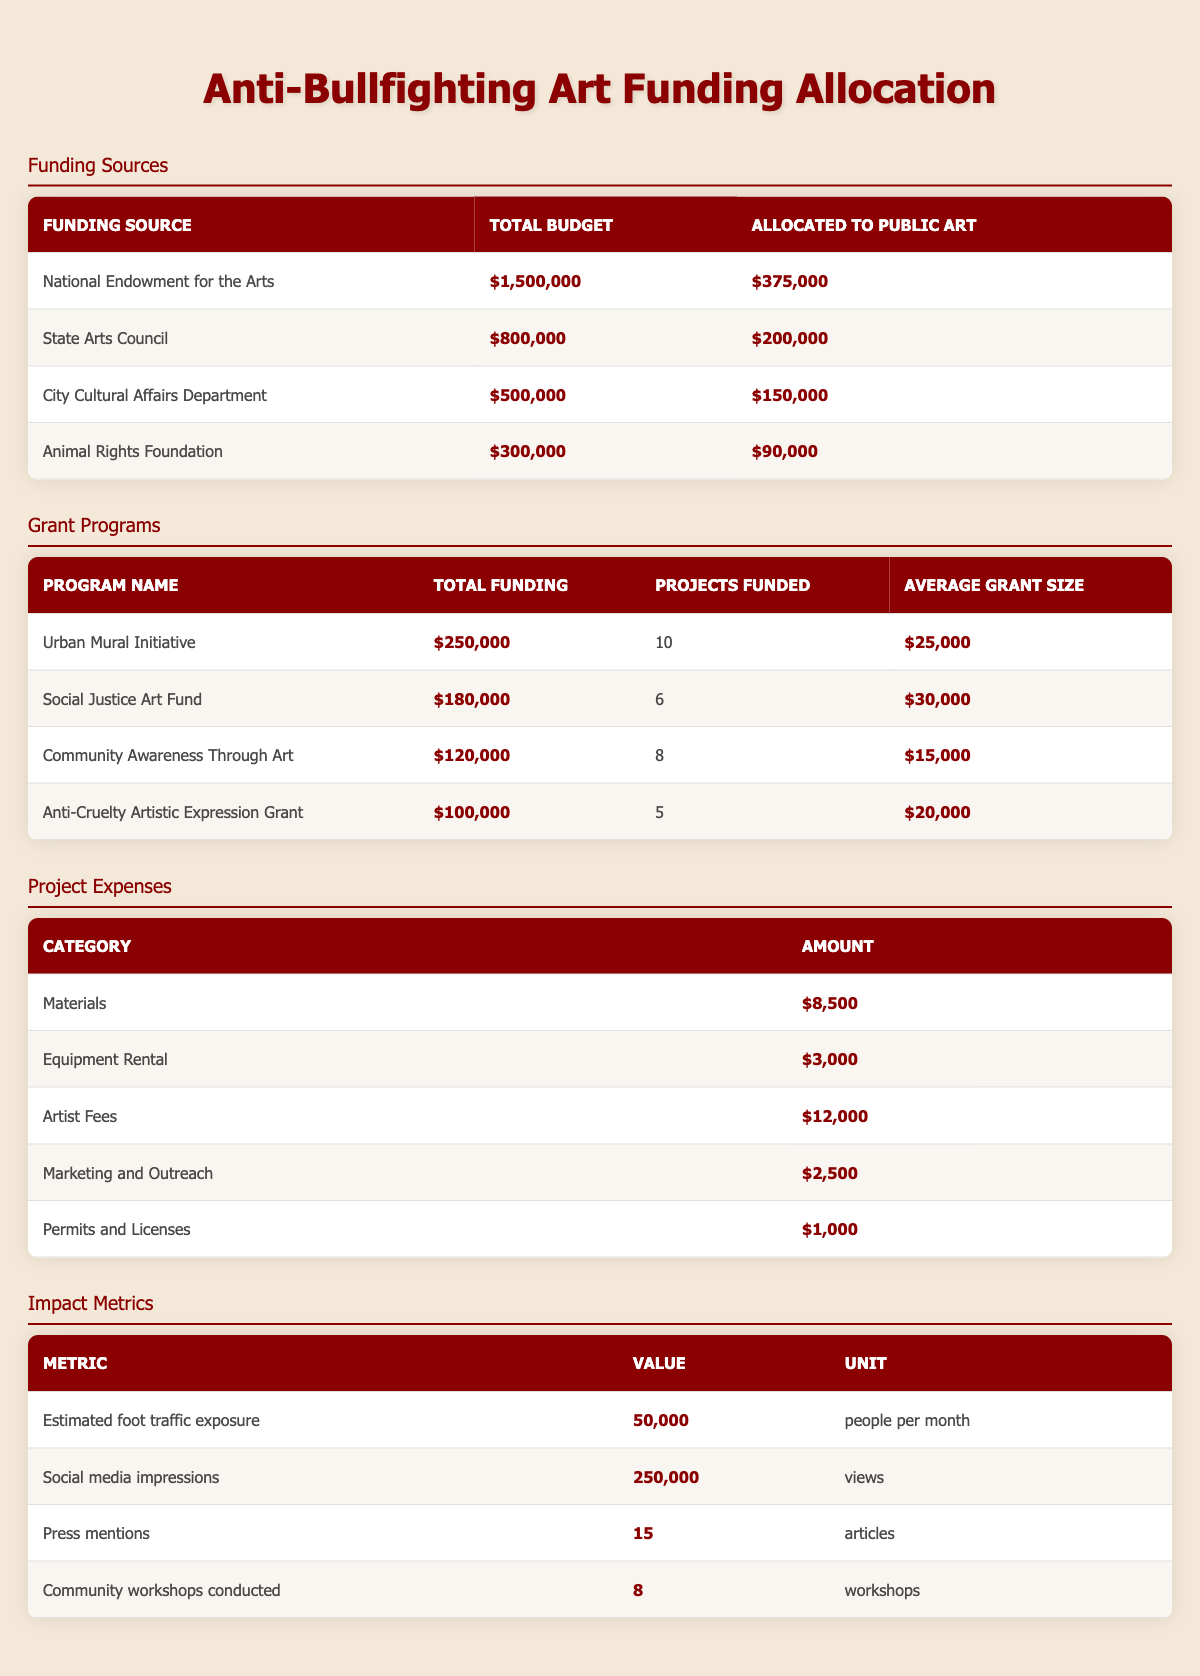What is the total amount allocated to public art from the National Endowment for the Arts? The total allocated amount for public art from the National Endowment for the Arts is listed as $375,000 in the table.
Answer: $375,000 What is the total funding for the Urban Mural Initiative? The table shows the Urban Mural Initiative's total funding amount as $250,000.
Answer: $250,000 How much more funding did the State Arts Council allocate to public art compared to the Animal Rights Foundation? The State Arts Council allocated $200,000 to public art while the Animal Rights Foundation allocated $90,000. The difference is calculated as $200,000 - $90,000 = $110,000.
Answer: $110,000 Are there more projects funded under the Social Justice Art Fund than the Anti-Cruelty Artistic Expression Grant? The Social Justice Art Fund funded 6 projects, while the Anti-Cruelty Artistic Expression Grant funded 5 projects. Since 6 is greater than 5, the answer is yes.
Answer: Yes What is the average amount spent on artist fees compared to materials? The artist fees amount is $12,000 and materials amount is $8,500. Average is calculated as ($12,000 + $8,500) / 2 = $10,250.
Answer: $10,250 What is the total amount allocated to public art across all funding sources? First, identify the allocated totals: $375,000 (National Endowment for the Arts) + $200,000 (State Arts Council) + $150,000 (City Cultural Affairs Department) + $90,000 (Animal Rights Foundation) = $815,000.
Answer: $815,000 Is the total funding for the Community Awareness Through Art greater than the combined funding of the Urban Mural Initiative and Anti-Cruelty Artistic Expression Grant? The total funding for Community Awareness Through Art is $120,000. The combined total of Urban Mural Initiative ($250,000) and Anti-Cruelty Artistic Expression Grant ($100,000) is $350,000. Since $120,000 is less than $350,000, the answer is no.
Answer: No What percentage of the total budget from the City Cultural Affairs Department is allocated to public art? The total budget of the City Cultural Affairs Department is $500,000, with an allocation of $150,000 to public art. The percentage is calculated as ($150,000 / $500,000) * 100 = 30%.
Answer: 30% 